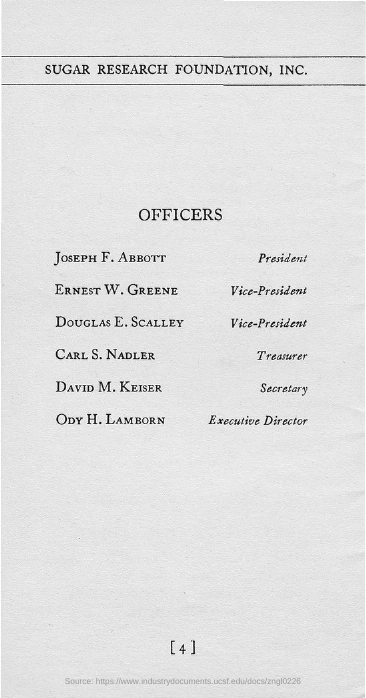Identify some key points in this picture. The president of Sugar Research Foundation, Inc. is Joseph F. Abbott. The Secretary of Sugar Research Foundation, Inc. is David M. Keiser. The Executive Director of Sugar Research Foundation, Inc. is ODY H. LAMBORN. The treasurer of Sugar Research Foundation, Inc. is Carl S. Nadler. 